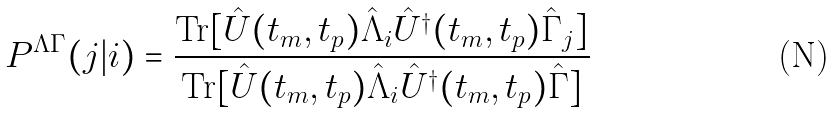Convert formula to latex. <formula><loc_0><loc_0><loc_500><loc_500>P ^ { \Lambda \Gamma } ( j | i ) = \frac { \text {Tr} [ \hat { U } ( t _ { m } , t _ { p } ) \hat { \Lambda } _ { i } \hat { U } ^ { \dagger } ( t _ { m } , t _ { p } ) \hat { \Gamma } _ { j } ] } { \text {Tr} [ \hat { U } ( t _ { m } , t _ { p } ) \hat { \Lambda } _ { i } \hat { U } ^ { \dagger } ( t _ { m } , t _ { p } ) \hat { \Gamma } ] }</formula> 